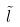Convert formula to latex. <formula><loc_0><loc_0><loc_500><loc_500>\tilde { l }</formula> 